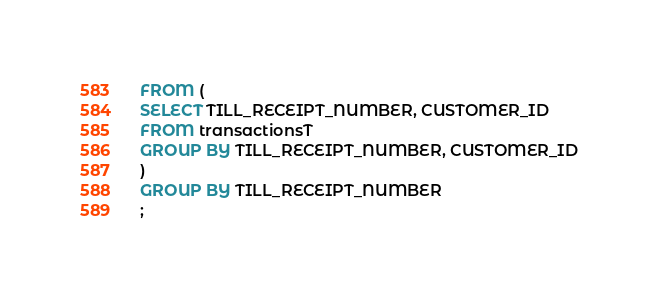<code> <loc_0><loc_0><loc_500><loc_500><_SQL_>FROM (
SELECT TILL_RECEIPT_NUMBER, CUSTOMER_ID
FROM transactionsT
GROUP BY TILL_RECEIPT_NUMBER, CUSTOMER_ID
)
GROUP BY TILL_RECEIPT_NUMBER
;</code> 